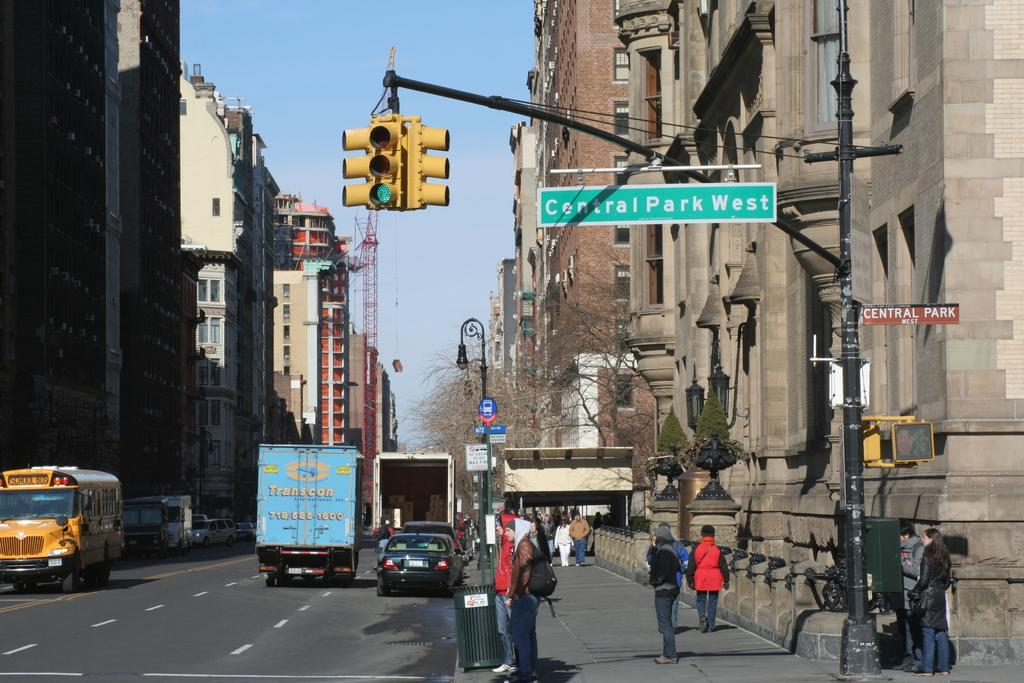<image>
Present a compact description of the photo's key features. A street sign for Central Park West hangs over the street. 